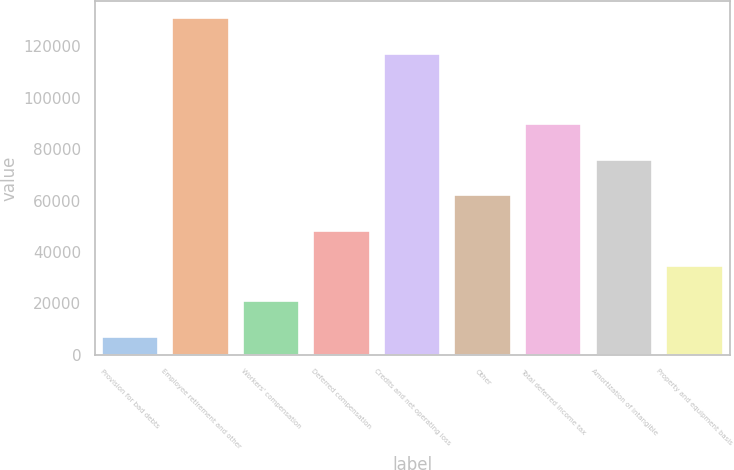Convert chart. <chart><loc_0><loc_0><loc_500><loc_500><bar_chart><fcel>Provision for bad debts<fcel>Employee retirement and other<fcel>Workers' compensation<fcel>Deferred compensation<fcel>Credits and net operating loss<fcel>Other<fcel>Total deferred income tax<fcel>Amortization of intangible<fcel>Property and equipment basis<nl><fcel>7123<fcel>130830<fcel>20868.2<fcel>48358.6<fcel>117085<fcel>62103.8<fcel>89594.2<fcel>75849<fcel>34613.4<nl></chart> 